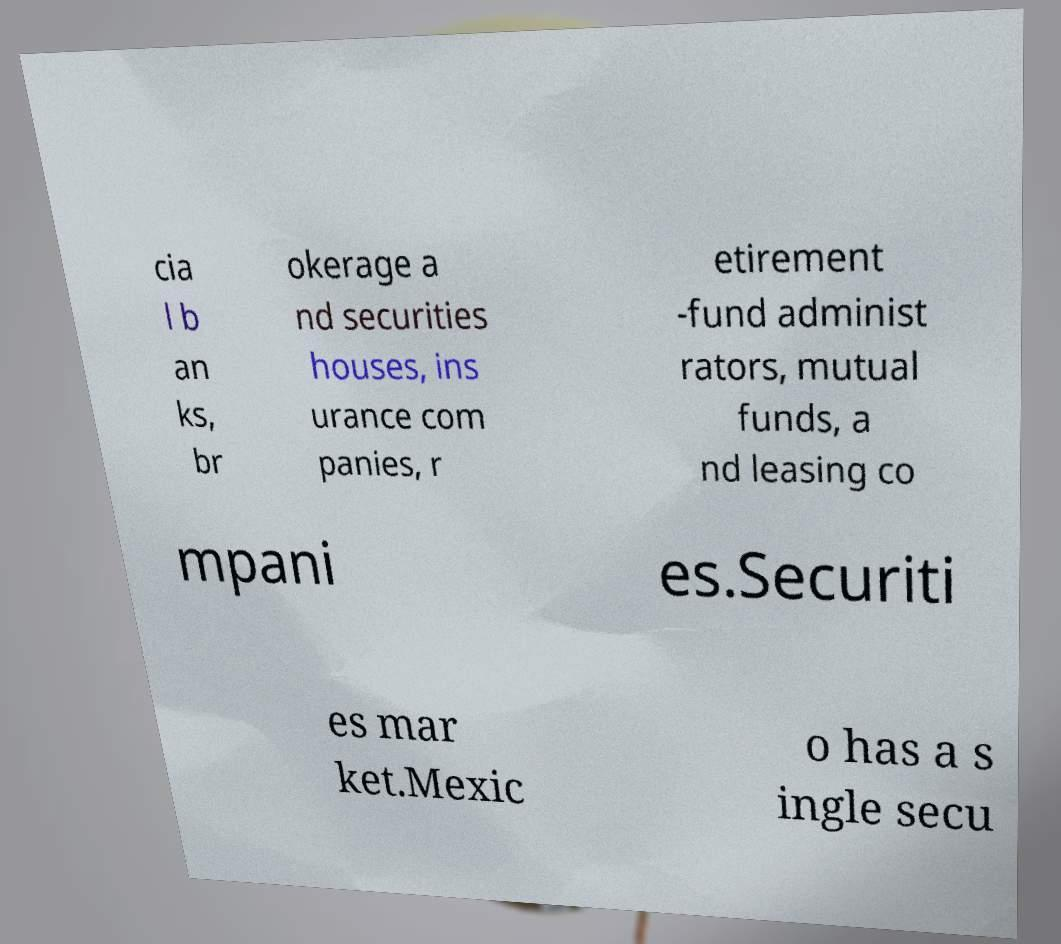Please read and relay the text visible in this image. What does it say? cia l b an ks, br okerage a nd securities houses, ins urance com panies, r etirement -fund administ rators, mutual funds, a nd leasing co mpani es.Securiti es mar ket.Mexic o has a s ingle secu 